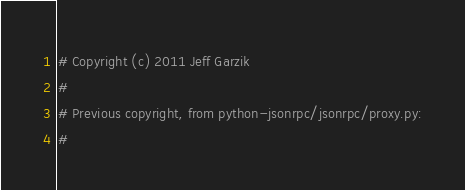Convert code to text. <code><loc_0><loc_0><loc_500><loc_500><_Python_># Copyright (c) 2011 Jeff Garzik
#
# Previous copyright, from python-jsonrpc/jsonrpc/proxy.py:
#</code> 